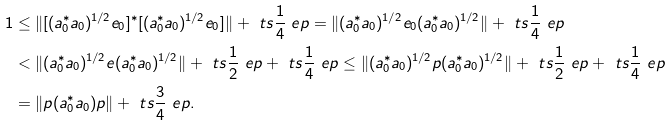<formula> <loc_0><loc_0><loc_500><loc_500>1 & \leq \| [ ( a _ { 0 } ^ { * } a _ { 0 } ) ^ { 1 / 2 } e _ { 0 } ] ^ { * } [ ( a _ { 0 } ^ { * } a _ { 0 } ) ^ { 1 / 2 } e _ { 0 } ] \| + \ t s { \frac { 1 } { 4 } } \ e p = \| ( a _ { 0 } ^ { * } a _ { 0 } ) ^ { 1 / 2 } e _ { 0 } ( a _ { 0 } ^ { * } a _ { 0 } ) ^ { 1 / 2 } \| + \ t s { \frac { 1 } { 4 } } \ e p \\ & < \| ( a _ { 0 } ^ { * } a _ { 0 } ) ^ { 1 / 2 } e ( a _ { 0 } ^ { * } a _ { 0 } ) ^ { 1 / 2 } \| + \ t s { \frac { 1 } { 2 } } \ e p + \ t s { \frac { 1 } { 4 } } \ e p \leq \| ( a _ { 0 } ^ { * } a _ { 0 } ) ^ { 1 / 2 } p ( a _ { 0 } ^ { * } a _ { 0 } ) ^ { 1 / 2 } \| + \ t s { \frac { 1 } { 2 } } \ e p + \ t s { \frac { 1 } { 4 } } \ e p \\ & = \| p ( a _ { 0 } ^ { * } a _ { 0 } ) p \| + \ t s { \frac { 3 } { 4 } } \ e p .</formula> 